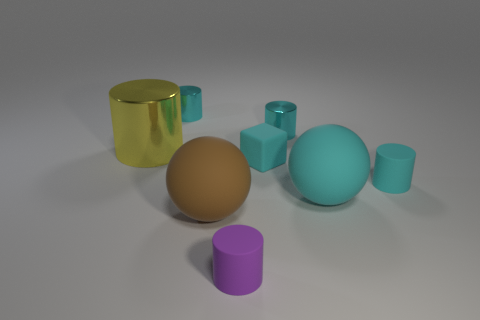How many cyan cylinders must be subtracted to get 1 cyan cylinders? 2 Subtract all tiny cylinders. How many cylinders are left? 1 Add 1 large purple metal objects. How many objects exist? 9 Subtract all green cubes. How many cyan cylinders are left? 3 Subtract 1 balls. How many balls are left? 1 Subtract all cylinders. How many objects are left? 3 Subtract all cyan spheres. How many spheres are left? 1 Subtract all large cyan balls. Subtract all metal cylinders. How many objects are left? 4 Add 7 big cyan rubber spheres. How many big cyan rubber spheres are left? 8 Add 7 gray metal spheres. How many gray metal spheres exist? 7 